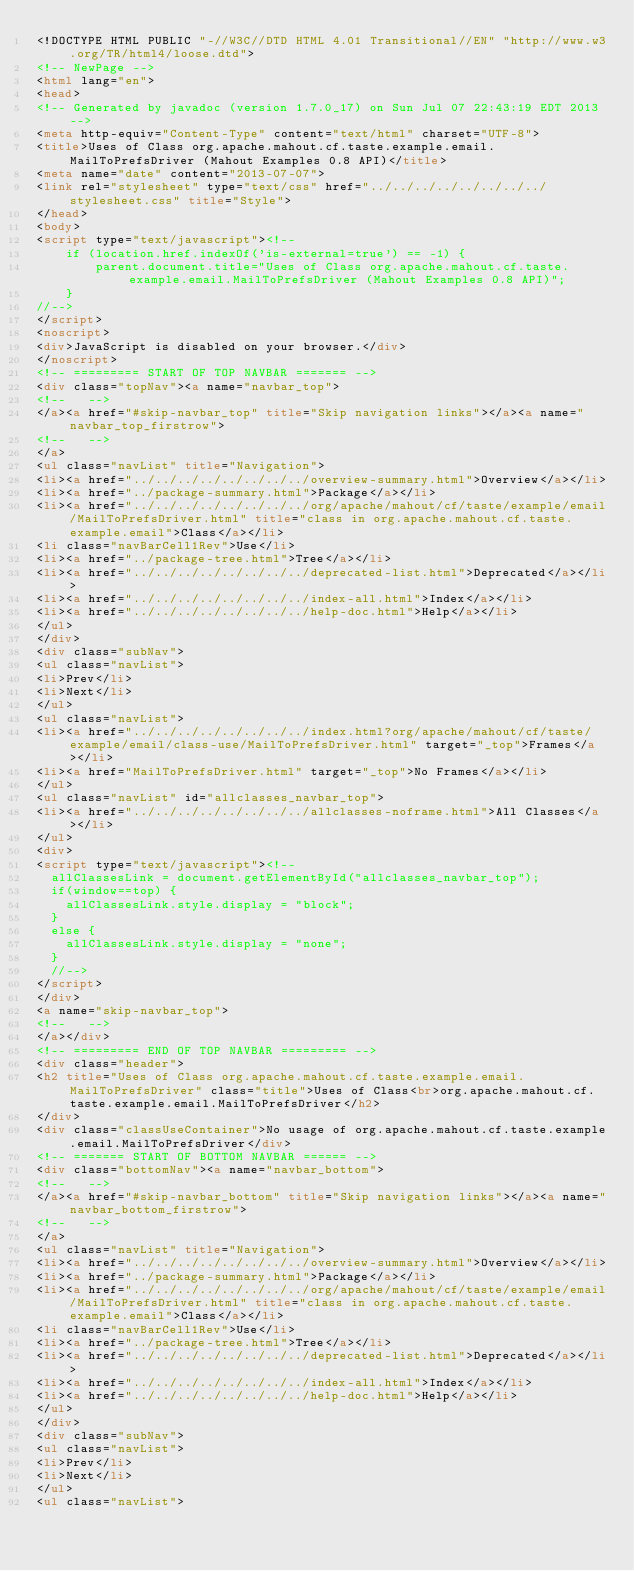<code> <loc_0><loc_0><loc_500><loc_500><_HTML_><!DOCTYPE HTML PUBLIC "-//W3C//DTD HTML 4.01 Transitional//EN" "http://www.w3.org/TR/html4/loose.dtd">
<!-- NewPage -->
<html lang="en">
<head>
<!-- Generated by javadoc (version 1.7.0_17) on Sun Jul 07 22:43:19 EDT 2013 -->
<meta http-equiv="Content-Type" content="text/html" charset="UTF-8">
<title>Uses of Class org.apache.mahout.cf.taste.example.email.MailToPrefsDriver (Mahout Examples 0.8 API)</title>
<meta name="date" content="2013-07-07">
<link rel="stylesheet" type="text/css" href="../../../../../../../../stylesheet.css" title="Style">
</head>
<body>
<script type="text/javascript"><!--
    if (location.href.indexOf('is-external=true') == -1) {
        parent.document.title="Uses of Class org.apache.mahout.cf.taste.example.email.MailToPrefsDriver (Mahout Examples 0.8 API)";
    }
//-->
</script>
<noscript>
<div>JavaScript is disabled on your browser.</div>
</noscript>
<!-- ========= START OF TOP NAVBAR ======= -->
<div class="topNav"><a name="navbar_top">
<!--   -->
</a><a href="#skip-navbar_top" title="Skip navigation links"></a><a name="navbar_top_firstrow">
<!--   -->
</a>
<ul class="navList" title="Navigation">
<li><a href="../../../../../../../../overview-summary.html">Overview</a></li>
<li><a href="../package-summary.html">Package</a></li>
<li><a href="../../../../../../../../org/apache/mahout/cf/taste/example/email/MailToPrefsDriver.html" title="class in org.apache.mahout.cf.taste.example.email">Class</a></li>
<li class="navBarCell1Rev">Use</li>
<li><a href="../package-tree.html">Tree</a></li>
<li><a href="../../../../../../../../deprecated-list.html">Deprecated</a></li>
<li><a href="../../../../../../../../index-all.html">Index</a></li>
<li><a href="../../../../../../../../help-doc.html">Help</a></li>
</ul>
</div>
<div class="subNav">
<ul class="navList">
<li>Prev</li>
<li>Next</li>
</ul>
<ul class="navList">
<li><a href="../../../../../../../../index.html?org/apache/mahout/cf/taste/example/email/class-use/MailToPrefsDriver.html" target="_top">Frames</a></li>
<li><a href="MailToPrefsDriver.html" target="_top">No Frames</a></li>
</ul>
<ul class="navList" id="allclasses_navbar_top">
<li><a href="../../../../../../../../allclasses-noframe.html">All Classes</a></li>
</ul>
<div>
<script type="text/javascript"><!--
  allClassesLink = document.getElementById("allclasses_navbar_top");
  if(window==top) {
    allClassesLink.style.display = "block";
  }
  else {
    allClassesLink.style.display = "none";
  }
  //-->
</script>
</div>
<a name="skip-navbar_top">
<!--   -->
</a></div>
<!-- ========= END OF TOP NAVBAR ========= -->
<div class="header">
<h2 title="Uses of Class org.apache.mahout.cf.taste.example.email.MailToPrefsDriver" class="title">Uses of Class<br>org.apache.mahout.cf.taste.example.email.MailToPrefsDriver</h2>
</div>
<div class="classUseContainer">No usage of org.apache.mahout.cf.taste.example.email.MailToPrefsDriver</div>
<!-- ======= START OF BOTTOM NAVBAR ====== -->
<div class="bottomNav"><a name="navbar_bottom">
<!--   -->
</a><a href="#skip-navbar_bottom" title="Skip navigation links"></a><a name="navbar_bottom_firstrow">
<!--   -->
</a>
<ul class="navList" title="Navigation">
<li><a href="../../../../../../../../overview-summary.html">Overview</a></li>
<li><a href="../package-summary.html">Package</a></li>
<li><a href="../../../../../../../../org/apache/mahout/cf/taste/example/email/MailToPrefsDriver.html" title="class in org.apache.mahout.cf.taste.example.email">Class</a></li>
<li class="navBarCell1Rev">Use</li>
<li><a href="../package-tree.html">Tree</a></li>
<li><a href="../../../../../../../../deprecated-list.html">Deprecated</a></li>
<li><a href="../../../../../../../../index-all.html">Index</a></li>
<li><a href="../../../../../../../../help-doc.html">Help</a></li>
</ul>
</div>
<div class="subNav">
<ul class="navList">
<li>Prev</li>
<li>Next</li>
</ul>
<ul class="navList"></code> 